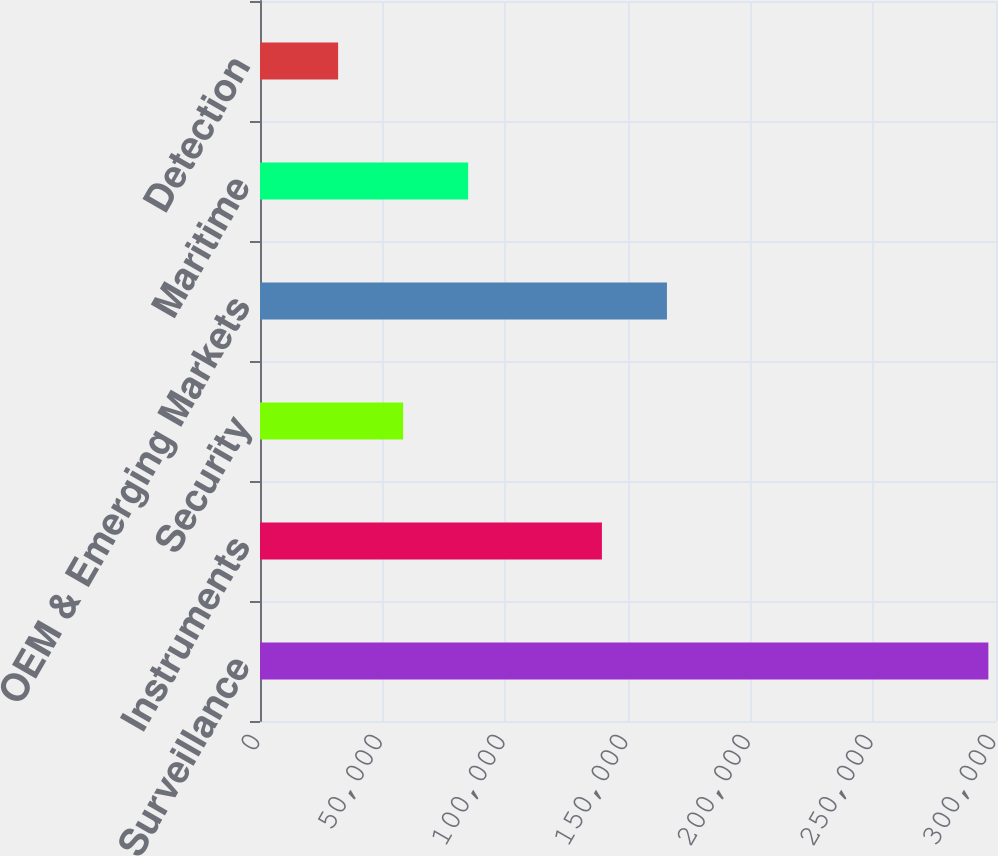<chart> <loc_0><loc_0><loc_500><loc_500><bar_chart><fcel>Surveillance<fcel>Instruments<fcel>Security<fcel>OEM & Emerging Markets<fcel>Maritime<fcel>Detection<nl><fcel>296891<fcel>139367<fcel>58346.9<fcel>165872<fcel>84851.8<fcel>31842<nl></chart> 